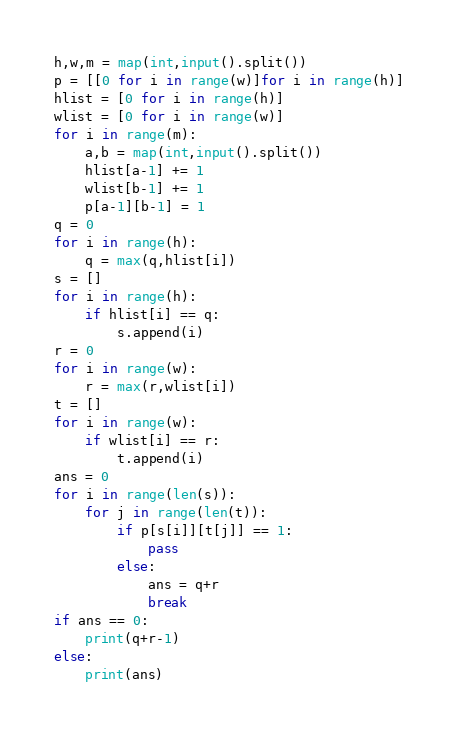<code> <loc_0><loc_0><loc_500><loc_500><_Python_>h,w,m = map(int,input().split())
p = [[0 for i in range(w)]for i in range(h)]
hlist = [0 for i in range(h)]
wlist = [0 for i in range(w)]
for i in range(m):
    a,b = map(int,input().split())
    hlist[a-1] += 1
    wlist[b-1] += 1
    p[a-1][b-1] = 1
q = 0
for i in range(h):
    q = max(q,hlist[i])
s = []
for i in range(h):
    if hlist[i] == q:
        s.append(i)
r = 0
for i in range(w):
    r = max(r,wlist[i])
t = []
for i in range(w):
    if wlist[i] == r:
        t.append(i)
ans = 0
for i in range(len(s)):
    for j in range(len(t)):
        if p[s[i]][t[j]] == 1:
            pass
        else:
            ans = q+r
            break
if ans == 0:
    print(q+r-1)
else:
    print(ans)</code> 